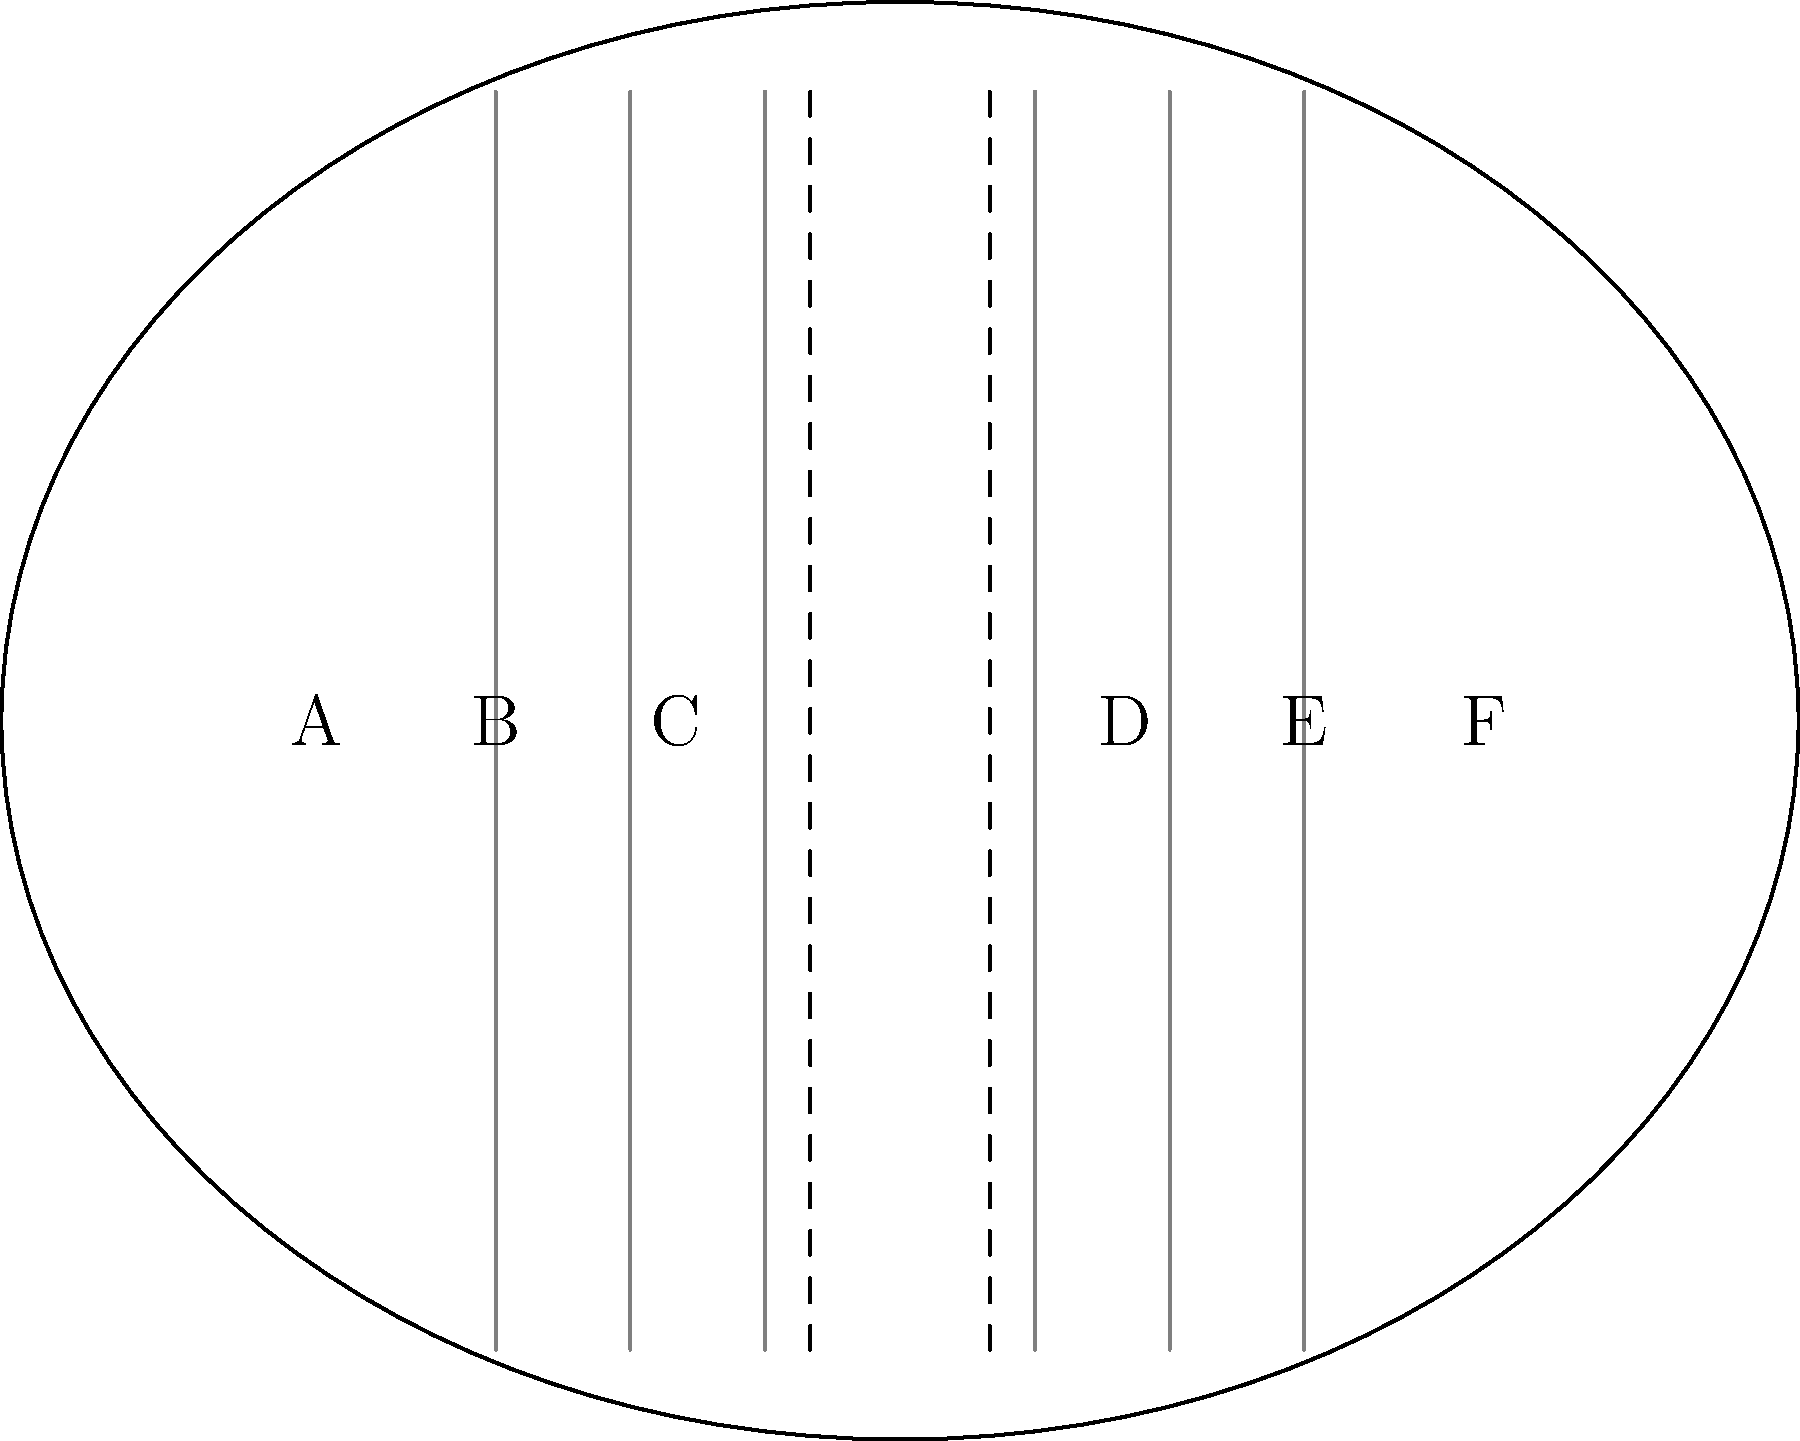Based on the cross-section diagram of an aircraft, what is the seating configuration and total passenger capacity per row for this particular airplane model? Assume all seats are economy class. To determine the seating configuration and total passenger capacity per row, we need to analyze the cross-section diagram:

1. Identify the seating arrangement:
   - We can see 6 seats labeled A, B, C, D, E, and F.
   - There is an aisle in the middle, separating seats C and D.

2. Determine the configuration:
   - On the left side of the aisle, we have 3 seats (A, B, C).
   - On the right side of the aisle, we have 3 seats (D, E, F).
   - This arrangement is known as a 3-3 configuration.

3. Calculate the total passenger capacity per row:
   - Left side: 3 seats
   - Right side: 3 seats
   - Total: 3 + 3 = 6 seats per row

Therefore, the seating configuration is 3-3, and the total passenger capacity per row is 6 seats.
Answer: 3-3 configuration, 6 seats per row 